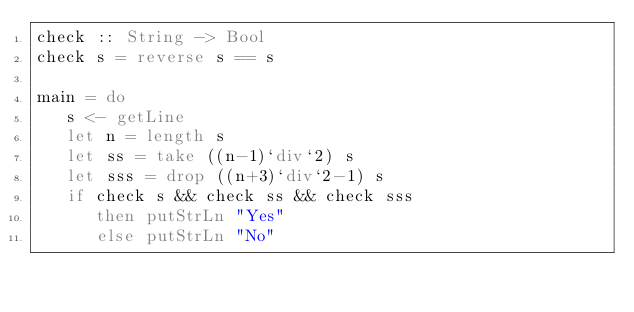Convert code to text. <code><loc_0><loc_0><loc_500><loc_500><_Haskell_>check :: String -> Bool
check s = reverse s == s

main = do
   s <- getLine
   let n = length s
   let ss = take ((n-1)`div`2) s
   let sss = drop ((n+3)`div`2-1) s
   if check s && check ss && check sss
      then putStrLn "Yes"
      else putStrLn "No"</code> 